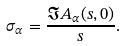Convert formula to latex. <formula><loc_0><loc_0><loc_500><loc_500>\sigma _ { \alpha } = \frac { \Im A _ { \alpha } ( s , 0 ) } { s } .</formula> 